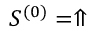Convert formula to latex. <formula><loc_0><loc_0><loc_500><loc_500>S ^ { ( 0 ) } = \Uparrow</formula> 